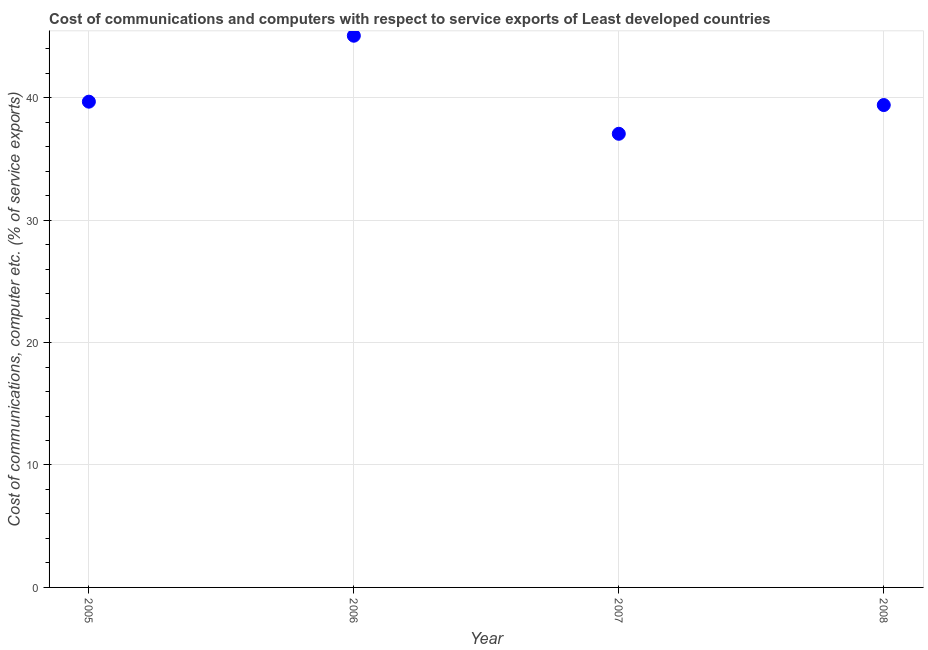What is the cost of communications and computer in 2007?
Make the answer very short. 37.05. Across all years, what is the maximum cost of communications and computer?
Ensure brevity in your answer.  45.06. Across all years, what is the minimum cost of communications and computer?
Ensure brevity in your answer.  37.05. In which year was the cost of communications and computer maximum?
Offer a very short reply. 2006. In which year was the cost of communications and computer minimum?
Your response must be concise. 2007. What is the sum of the cost of communications and computer?
Your answer should be very brief. 161.17. What is the difference between the cost of communications and computer in 2006 and 2008?
Provide a short and direct response. 5.66. What is the average cost of communications and computer per year?
Your answer should be compact. 40.29. What is the median cost of communications and computer?
Provide a short and direct response. 39.53. In how many years, is the cost of communications and computer greater than 36 %?
Your response must be concise. 4. What is the ratio of the cost of communications and computer in 2005 to that in 2008?
Provide a succinct answer. 1.01. Is the cost of communications and computer in 2007 less than that in 2008?
Your response must be concise. Yes. Is the difference between the cost of communications and computer in 2005 and 2006 greater than the difference between any two years?
Provide a short and direct response. No. What is the difference between the highest and the second highest cost of communications and computer?
Ensure brevity in your answer.  5.39. Is the sum of the cost of communications and computer in 2005 and 2008 greater than the maximum cost of communications and computer across all years?
Offer a terse response. Yes. What is the difference between the highest and the lowest cost of communications and computer?
Make the answer very short. 8.01. How many years are there in the graph?
Offer a terse response. 4. Does the graph contain any zero values?
Make the answer very short. No. Does the graph contain grids?
Your response must be concise. Yes. What is the title of the graph?
Make the answer very short. Cost of communications and computers with respect to service exports of Least developed countries. What is the label or title of the Y-axis?
Your answer should be compact. Cost of communications, computer etc. (% of service exports). What is the Cost of communications, computer etc. (% of service exports) in 2005?
Offer a very short reply. 39.67. What is the Cost of communications, computer etc. (% of service exports) in 2006?
Ensure brevity in your answer.  45.06. What is the Cost of communications, computer etc. (% of service exports) in 2007?
Give a very brief answer. 37.05. What is the Cost of communications, computer etc. (% of service exports) in 2008?
Offer a terse response. 39.4. What is the difference between the Cost of communications, computer etc. (% of service exports) in 2005 and 2006?
Provide a short and direct response. -5.39. What is the difference between the Cost of communications, computer etc. (% of service exports) in 2005 and 2007?
Keep it short and to the point. 2.62. What is the difference between the Cost of communications, computer etc. (% of service exports) in 2005 and 2008?
Give a very brief answer. 0.28. What is the difference between the Cost of communications, computer etc. (% of service exports) in 2006 and 2007?
Offer a terse response. 8.01. What is the difference between the Cost of communications, computer etc. (% of service exports) in 2006 and 2008?
Ensure brevity in your answer.  5.66. What is the difference between the Cost of communications, computer etc. (% of service exports) in 2007 and 2008?
Ensure brevity in your answer.  -2.35. What is the ratio of the Cost of communications, computer etc. (% of service exports) in 2005 to that in 2006?
Your response must be concise. 0.88. What is the ratio of the Cost of communications, computer etc. (% of service exports) in 2005 to that in 2007?
Your answer should be compact. 1.07. What is the ratio of the Cost of communications, computer etc. (% of service exports) in 2006 to that in 2007?
Provide a succinct answer. 1.22. What is the ratio of the Cost of communications, computer etc. (% of service exports) in 2006 to that in 2008?
Your response must be concise. 1.14. What is the ratio of the Cost of communications, computer etc. (% of service exports) in 2007 to that in 2008?
Provide a short and direct response. 0.94. 